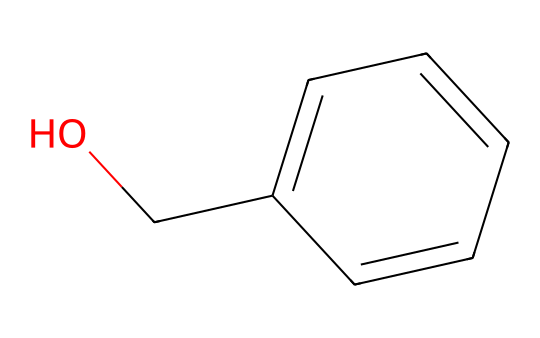What is the name of this chemical? The SMILES representation provided shows the structural formula for benzyl alcohol, which consists of a benzene ring (c1ccccc1) with a hydroxyl group (-OH) attached to it (OC).
Answer: benzyl alcohol How many carbon atoms are in benzyl alcohol? The structure reveals that there are seven carbon atoms in total: six from the benzene ring (c1ccccc1) and one from the hydroxymethyl group (OC).
Answer: seven What is the functional group present in benzyl alcohol? The -OH group attached to the benzene ring is the hydroxyl functional group, which characterizes alcohols.
Answer: hydroxyl How many hydrogen atoms are present in benzyl alcohol? Counting the hydrogen atoms, there are eight: five from the five carbon atoms in the benzene ring (since each carbon typically bonds to one hydrogen), one from the additional carbon in the hydroxymethyl part, and one from the hydroxyl group.
Answer: eight Is benzyl alcohol considered a polar or nonpolar solvent? The presence of the hydroxyl (-OH) group indicates that benzyl alcohol is polar due to its ability to form hydrogen bonds and its overall structure, which allows for such interactions.
Answer: polar What type of solvent is benzyl alcohol primarily classified as? Benzyl alcohol is classified as a polar aprotic solvent, meaning it can dissolve polar substances without forming hydrogen bonds with them.
Answer: polar aprotic solvent Which element gives benzyl alcohol its aromatic character? The carbon atoms in the benzene ring impart aromaticity to benzyl alcohol, which is a key characteristic of aromatic compounds.
Answer: carbon 